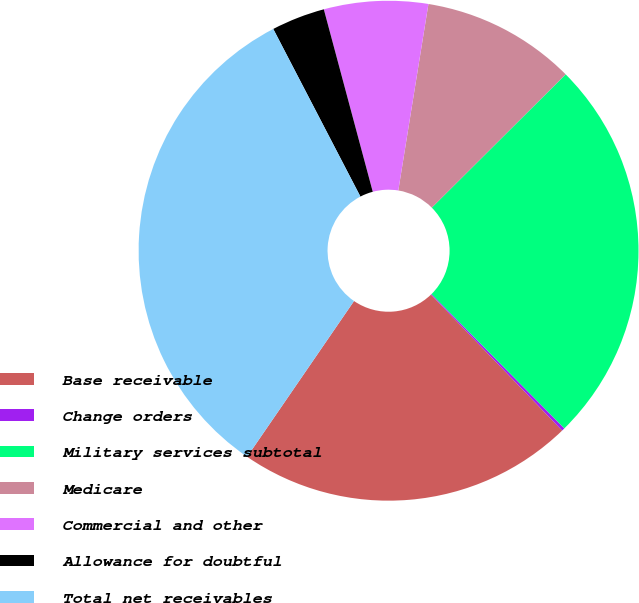Convert chart. <chart><loc_0><loc_0><loc_500><loc_500><pie_chart><fcel>Base receivable<fcel>Change orders<fcel>Military services subtotal<fcel>Medicare<fcel>Commercial and other<fcel>Allowance for doubtful<fcel>Total net receivables<nl><fcel>21.79%<fcel>0.2%<fcel>25.05%<fcel>9.98%<fcel>6.72%<fcel>3.46%<fcel>32.79%<nl></chart> 